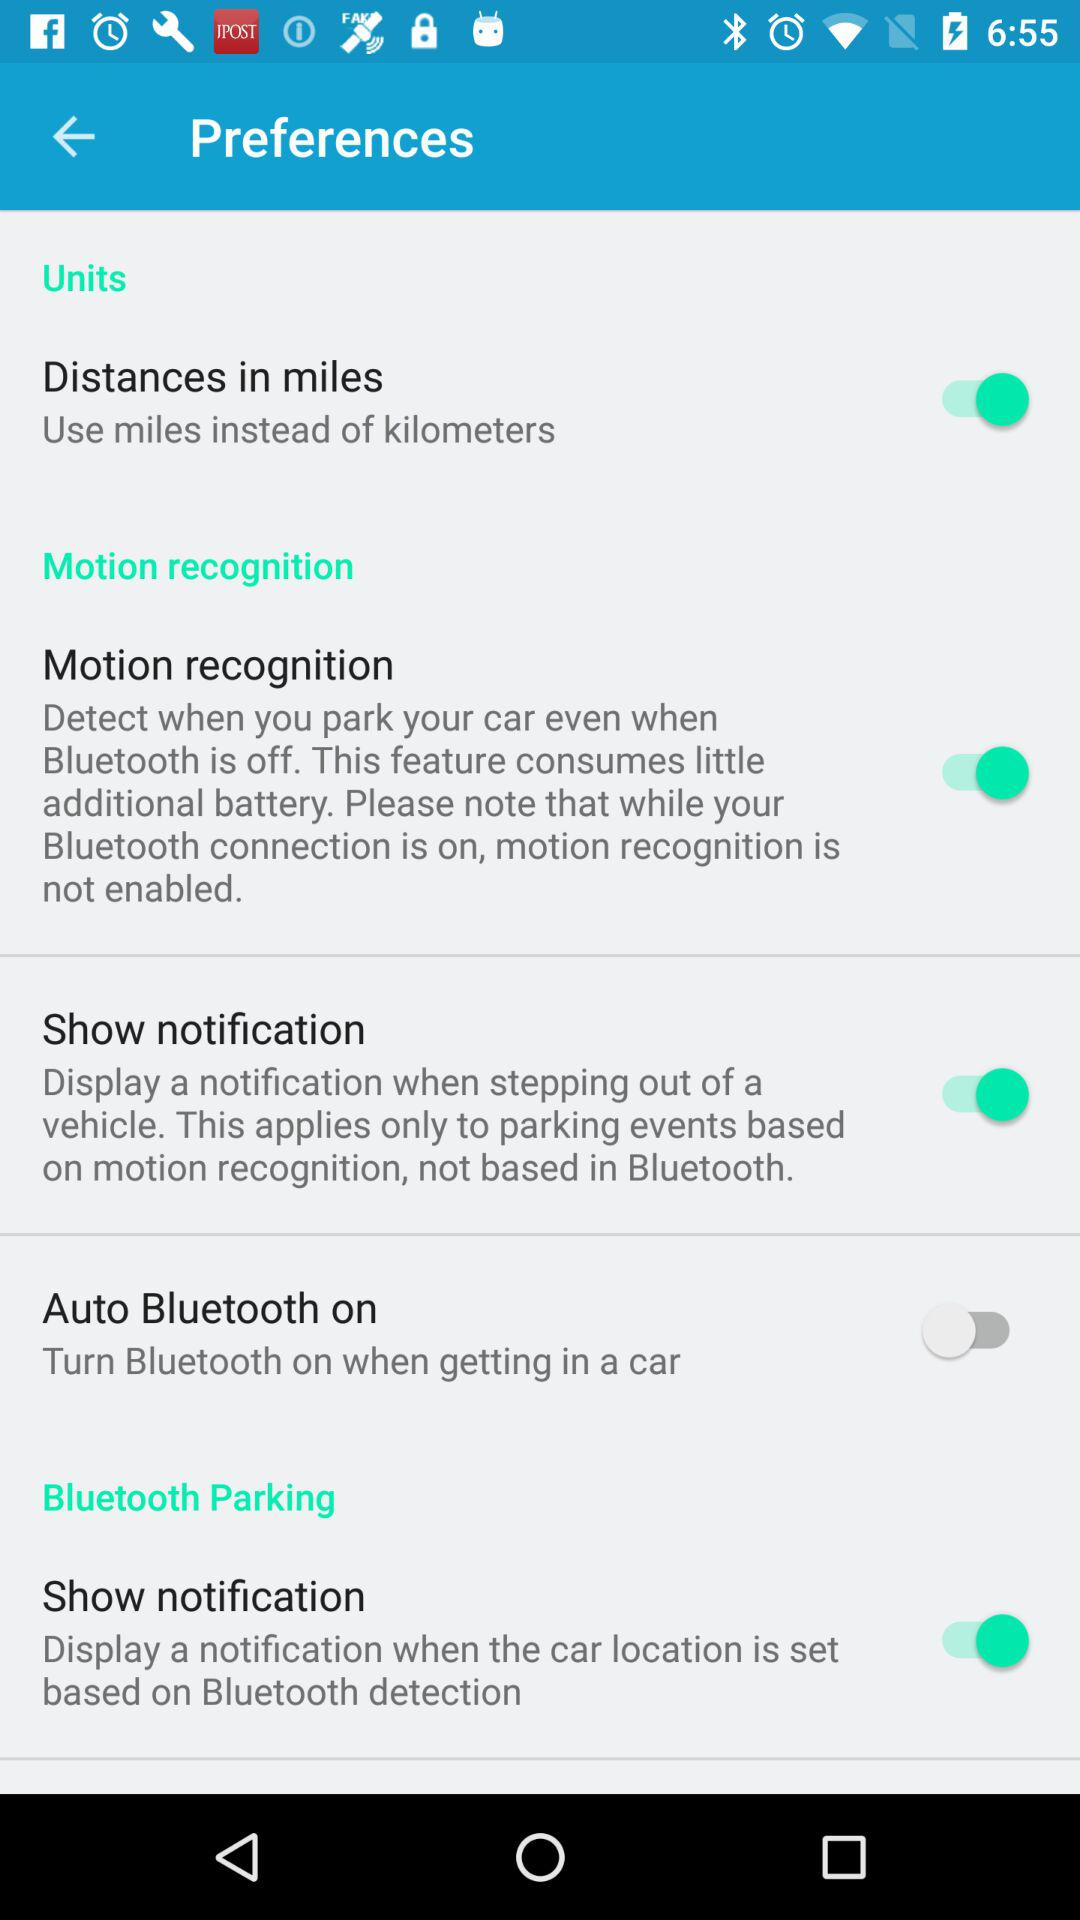What are the units of distance? The units of distance are miles and kilometers. 